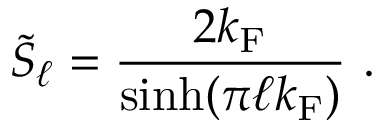<formula> <loc_0><loc_0><loc_500><loc_500>\tilde { S } _ { \ell } = \frac { 2 k _ { F } } { \sinh ( \pi \ell k _ { F } ) } \ .</formula> 